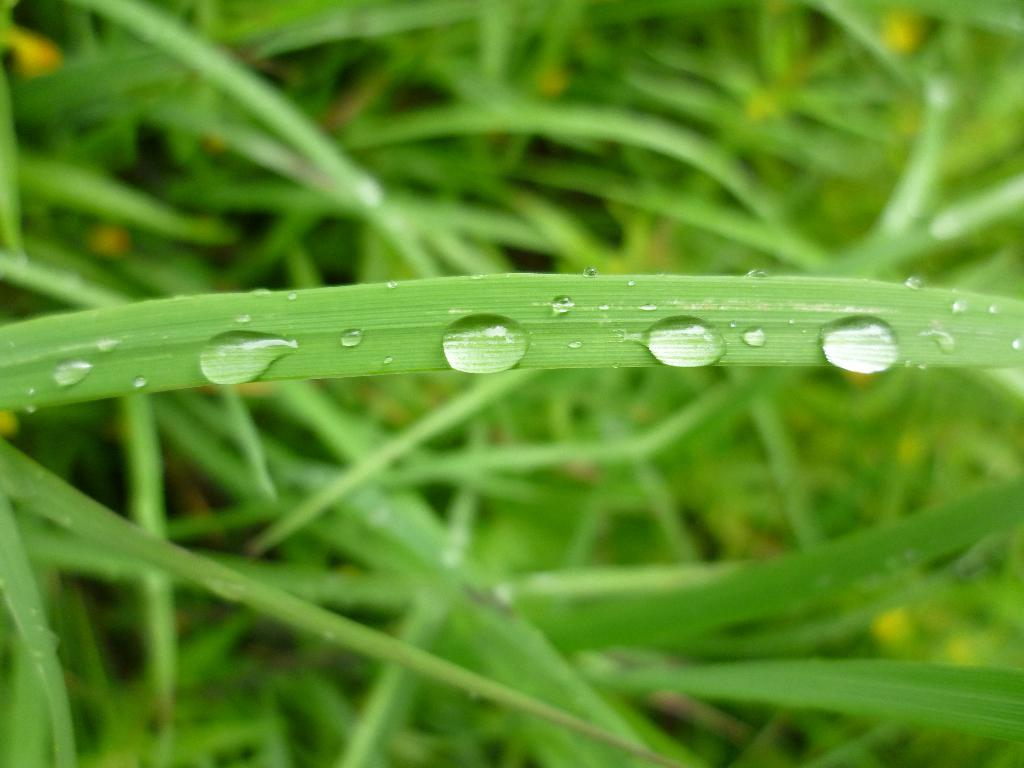What is present on the leaf in the image? There are water drops on a leaf in the image. How would you describe the appearance of the background in the image? The background of the image is blurred. What type of objects can be seen in the background of the image? There are plants visible in the background of the image. What substance is being locked in the place shown in the image? There is no substance being locked in a place in the image; it features water drops on a leaf with a blurred background and plants in the background. 